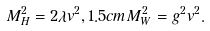Convert formula to latex. <formula><loc_0><loc_0><loc_500><loc_500>M _ { H } ^ { 2 } = 2 \lambda v ^ { 2 } , 1 . 5 c m M _ { W } ^ { 2 } = g ^ { 2 } v ^ { 2 } .</formula> 